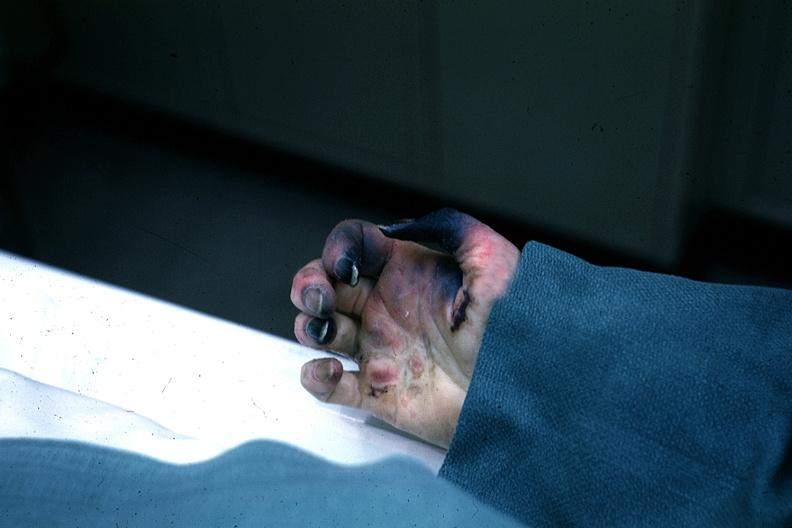how is excellent gangrenous necrosis of fingers said to be to embolism?
Answer the question using a single word or phrase. Due 